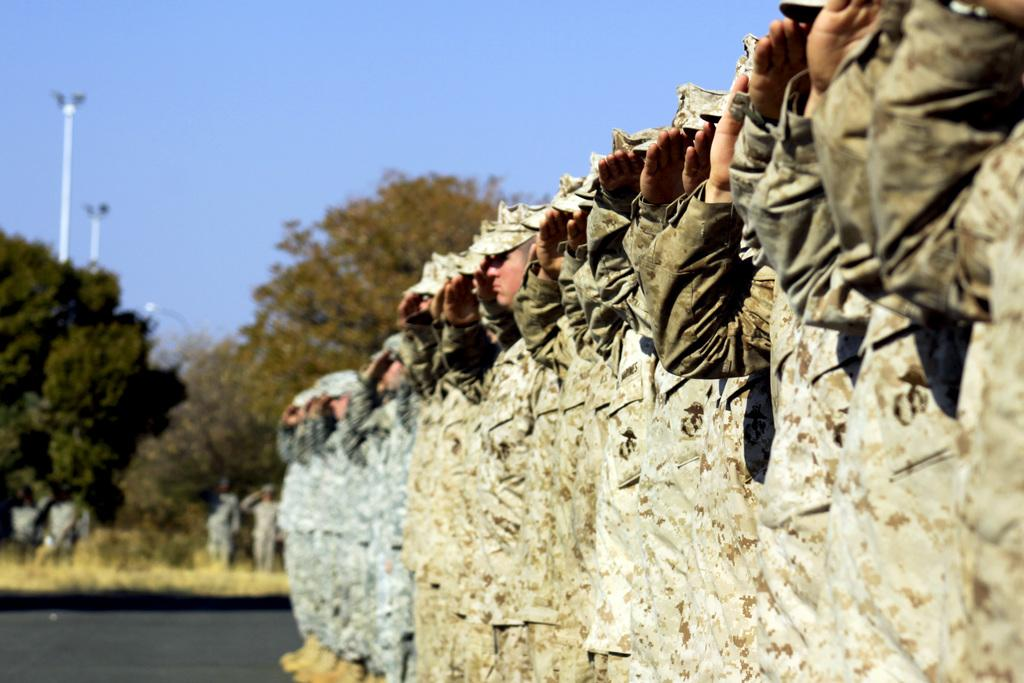What can be seen on the road in the image? There are men standing on the road in the image. How are the men positioned in relation to each other? The men are standing in the same position in the image. What is visible in the background of the image? There is sky, trees, and poles visible in the background of the image. What type of fact can be seen in the stomach of the men in the image? There is no fact visible in the stomach of the men in the image, as the image does not show any internal organs or details about their bodies. 